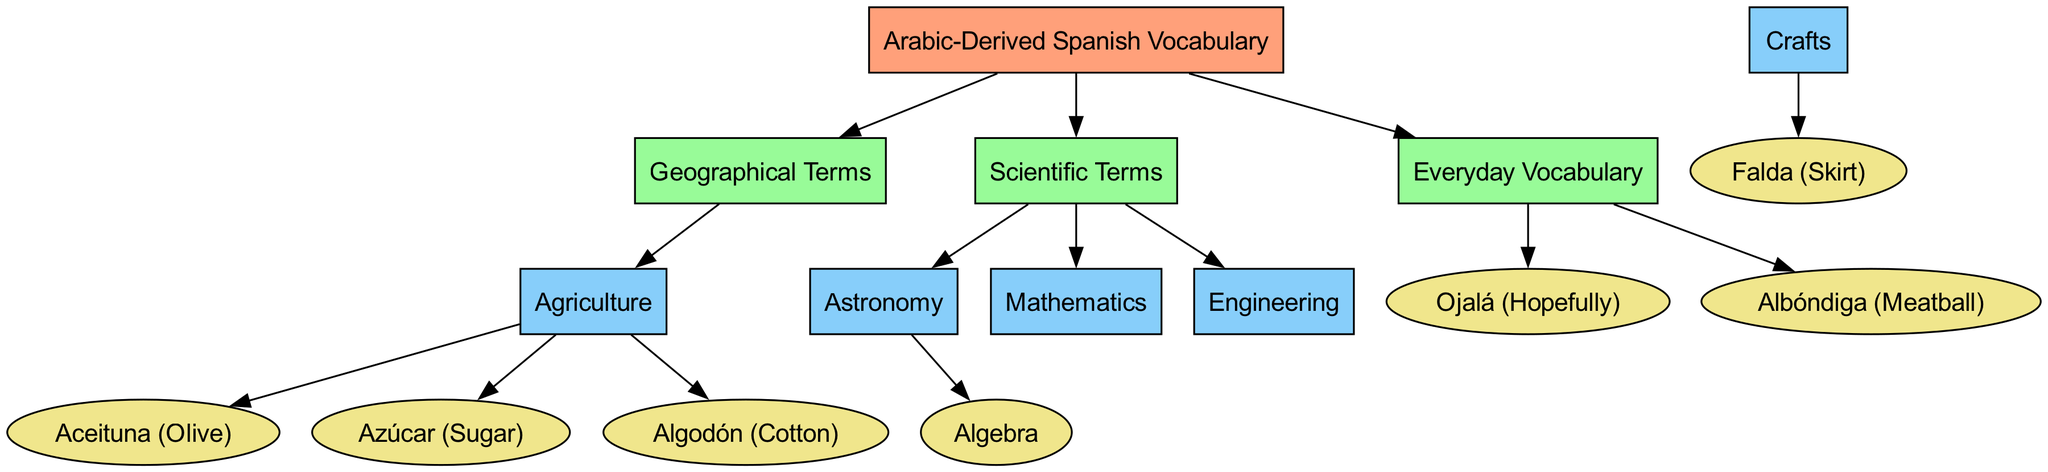What are the three main categories of Arabic-derived Spanish vocabulary? The diagram shows a root node connected to three main categories: Geography, Science, and Everyday Vocabulary. These categories represent the major themes of vocabulary derived from Arabic.
Answer: Geography, Science, Everyday Vocabulary How many nodes are in the diagram? The diagram identifies a total of 14 nodes, which include the root node and various categories, subcategories, and specific words. Nodes are defined where each represents a distinct concept or term relevant to Arabic-derived vocabulary.
Answer: 14 What is a specific word derived from Arabic in the category of Everyday Vocabulary? Within the Everyday Vocabulary category, the diagram highlights the word "Ojalá," which is a common Spanish term. This term is grouped under the Everyday node, indicating its frequent usage in everyday language.
Answer: Ojalá Which category includes the term "Aceituna"? The term "Aceituna" falls under the Agriculture category according to the diagram. The edge connections demonstrate that this word is part of the vocabulary related to agricultural concepts and practices.
Answer: Agriculture How many edges connect the Geography category to its subcategories? The Geography category has one edge connecting it to the Agriculture subcategory, indicating a direct link and signifying that geographical terms have a relationship with agriculture in the context of Arabic-derived vocabulary.
Answer: 1 What is the relationship between the Astronomy and Algebra nodes? The diagram shows an edge from the Astronomy category to the Algebra node, indicating that Algebra is a sub-discipline within the field of Astronomy in the context of Arabic-derived Spanish vocabulary. This shows how different scientific terminologies are interrelated.
Answer: Algebra Which two fields fall under the Science category? The Science category includes three subfields: Astronomy, Mathematics, and Engineering. To identify specifically two, we can name Astronomy and Mathematics, as both are prominently placed under the Science node in the diagram.
Answer: Astronomy, Mathematics What color represents the root node? The root node is represented in a light coral color, specified in the color scheme in the diagram, which visually distinguishes it from the other nodes, primarily categorized by their functions and connections.
Answer: Light Coral Which term is used for 'skirt' in Spanish? The diagram indicates that the Spanish word for skirt derived from Arabic is "Falda." This word is placed in the Crafts category, linking it specifically to crafts and clothing vocabulary.
Answer: Falda 